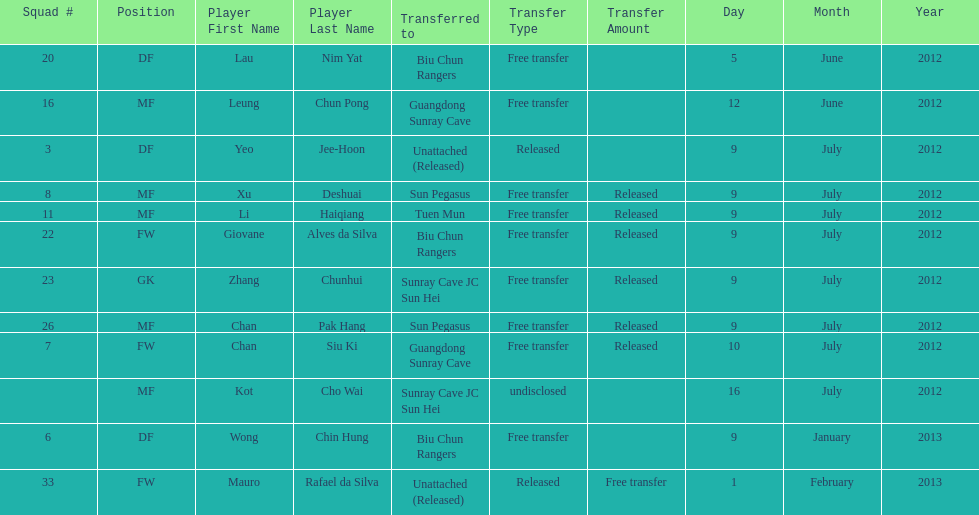Player transferred immediately before mauro rafael da silva Wong Chin Hung. 